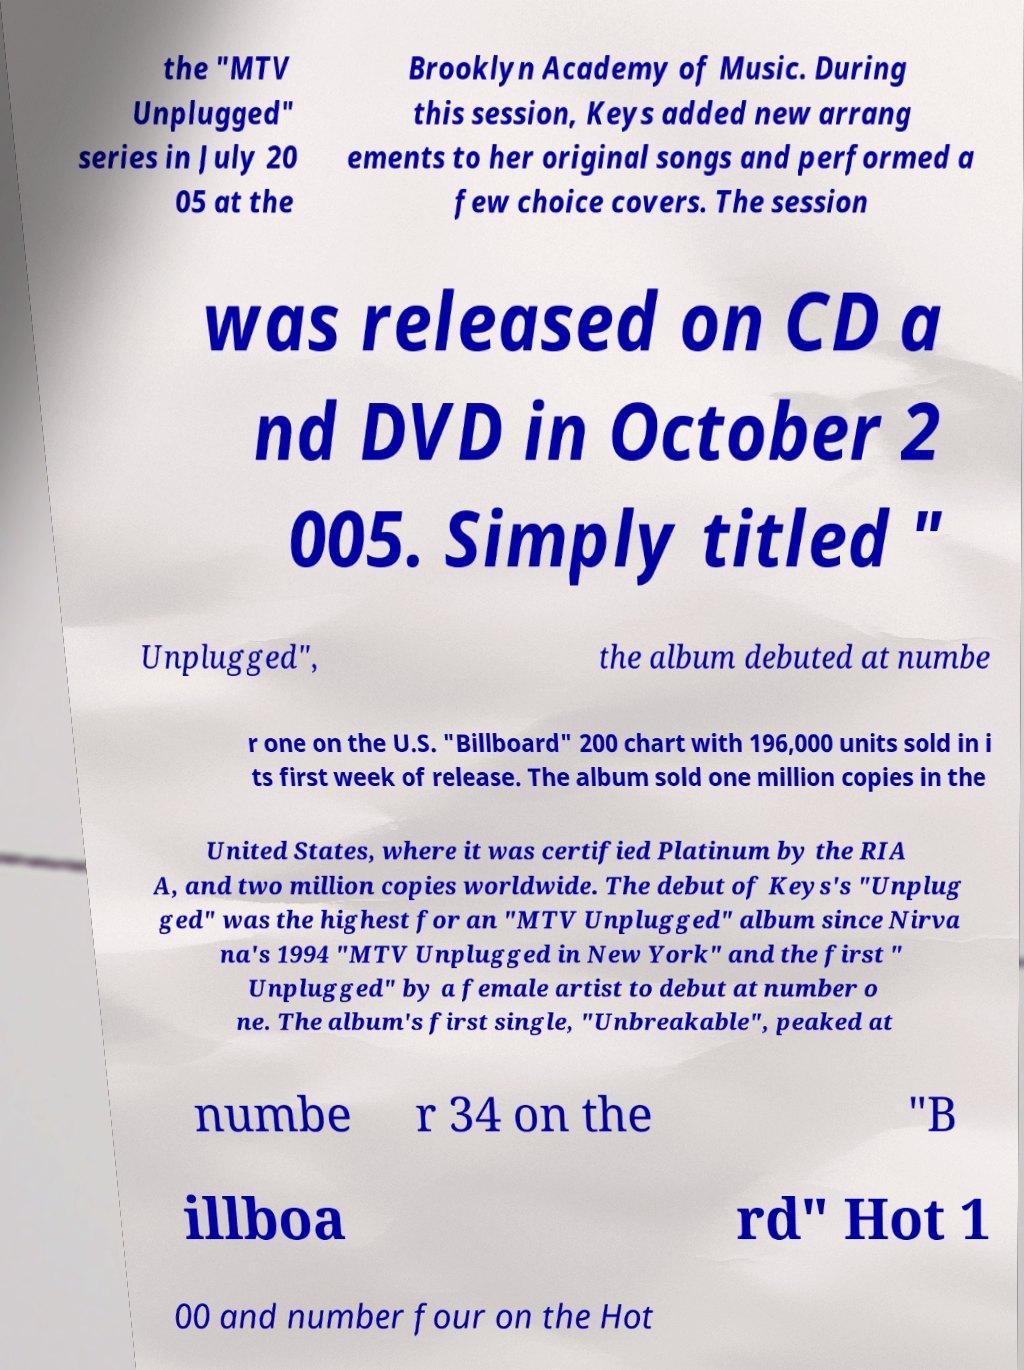Can you accurately transcribe the text from the provided image for me? the "MTV Unplugged" series in July 20 05 at the Brooklyn Academy of Music. During this session, Keys added new arrang ements to her original songs and performed a few choice covers. The session was released on CD a nd DVD in October 2 005. Simply titled " Unplugged", the album debuted at numbe r one on the U.S. "Billboard" 200 chart with 196,000 units sold in i ts first week of release. The album sold one million copies in the United States, where it was certified Platinum by the RIA A, and two million copies worldwide. The debut of Keys's "Unplug ged" was the highest for an "MTV Unplugged" album since Nirva na's 1994 "MTV Unplugged in New York" and the first " Unplugged" by a female artist to debut at number o ne. The album's first single, "Unbreakable", peaked at numbe r 34 on the "B illboa rd" Hot 1 00 and number four on the Hot 